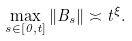<formula> <loc_0><loc_0><loc_500><loc_500>\max _ { s \in [ 0 , t ] } \| B _ { s } \| \asymp t ^ { \xi } .</formula> 